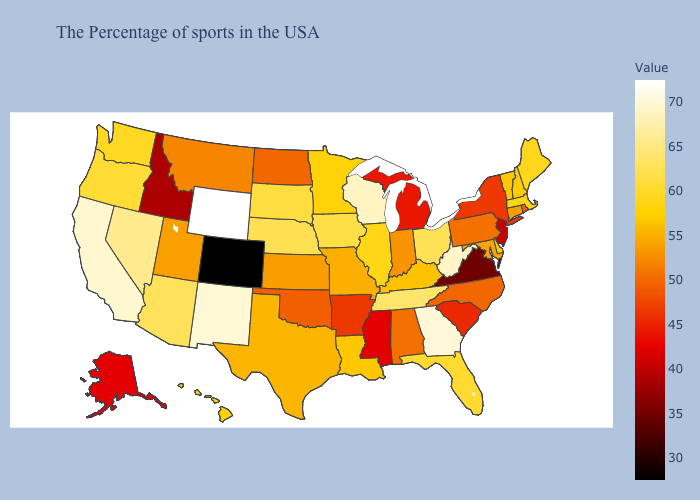Which states hav the highest value in the West?
Be succinct. Wyoming. Among the states that border Wisconsin , does Michigan have the lowest value?
Short answer required. Yes. Does Idaho have the lowest value in the USA?
Concise answer only. No. Among the states that border Utah , does Wyoming have the highest value?
Give a very brief answer. Yes. Does the map have missing data?
Be succinct. No. Among the states that border Georgia , which have the lowest value?
Short answer required. South Carolina. Does Indiana have a higher value than Oregon?
Give a very brief answer. No. Is the legend a continuous bar?
Answer briefly. Yes. 